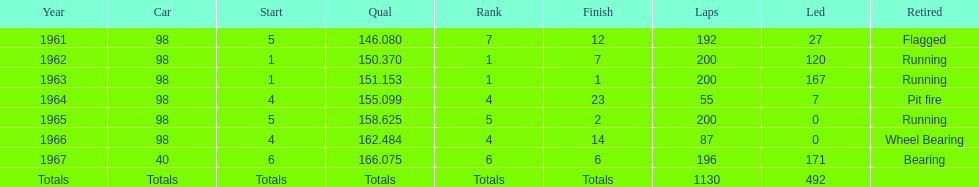How many times did he finish in the top three? 2. 